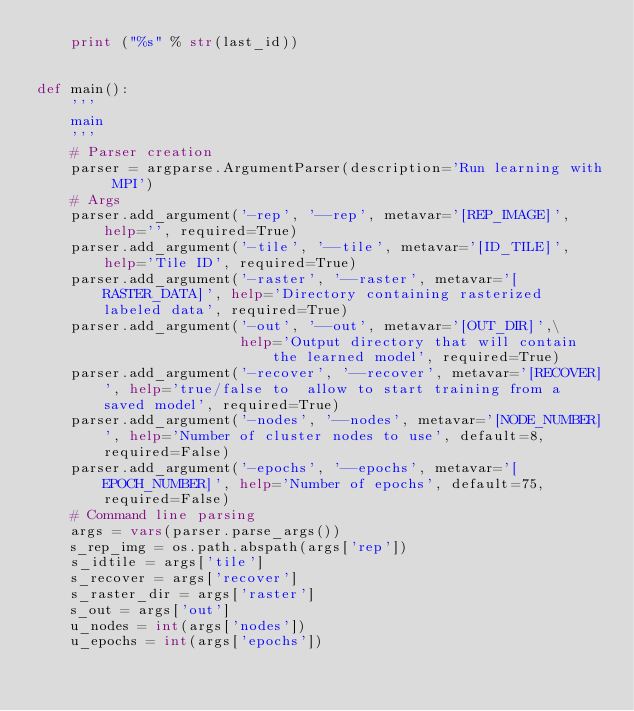<code> <loc_0><loc_0><loc_500><loc_500><_Python_>    print ("%s" % str(last_id))


def main():
    '''
    main
    '''
    # Parser creation
    parser = argparse.ArgumentParser(description='Run learning with MPI')
    # Args
    parser.add_argument('-rep', '--rep', metavar='[REP_IMAGE]', help='', required=True)
    parser.add_argument('-tile', '--tile', metavar='[ID_TILE]', help='Tile ID', required=True)
    parser.add_argument('-raster', '--raster', metavar='[RASTER_DATA]', help='Directory containing rasterized labeled data', required=True)
    parser.add_argument('-out', '--out', metavar='[OUT_DIR]',\
                        help='Output directory that will contain the learned model', required=True)
    parser.add_argument('-recover', '--recover', metavar='[RECOVER]', help='true/false to  allow to start training from a saved model', required=True)
    parser.add_argument('-nodes', '--nodes', metavar='[NODE_NUMBER]', help='Number of cluster nodes to use', default=8, required=False)
    parser.add_argument('-epochs', '--epochs', metavar='[EPOCH_NUMBER]', help='Number of epochs', default=75, required=False)
    # Command line parsing
    args = vars(parser.parse_args())
    s_rep_img = os.path.abspath(args['rep'])
    s_idtile = args['tile']
    s_recover = args['recover']
    s_raster_dir = args['raster']
    s_out = args['out']
    u_nodes = int(args['nodes'])
    u_epochs = int(args['epochs'])</code> 